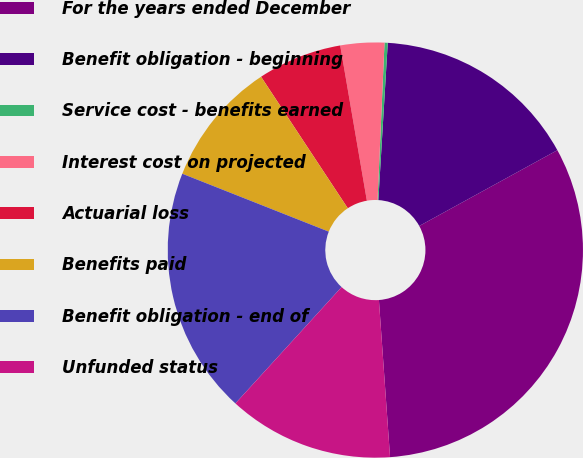<chart> <loc_0><loc_0><loc_500><loc_500><pie_chart><fcel>For the years ended December<fcel>Benefit obligation - beginning<fcel>Service cost - benefits earned<fcel>Interest cost on projected<fcel>Actuarial loss<fcel>Benefits paid<fcel>Benefit obligation - end of<fcel>Unfunded status<nl><fcel>31.86%<fcel>16.06%<fcel>0.25%<fcel>3.41%<fcel>6.57%<fcel>9.73%<fcel>19.22%<fcel>12.9%<nl></chart> 